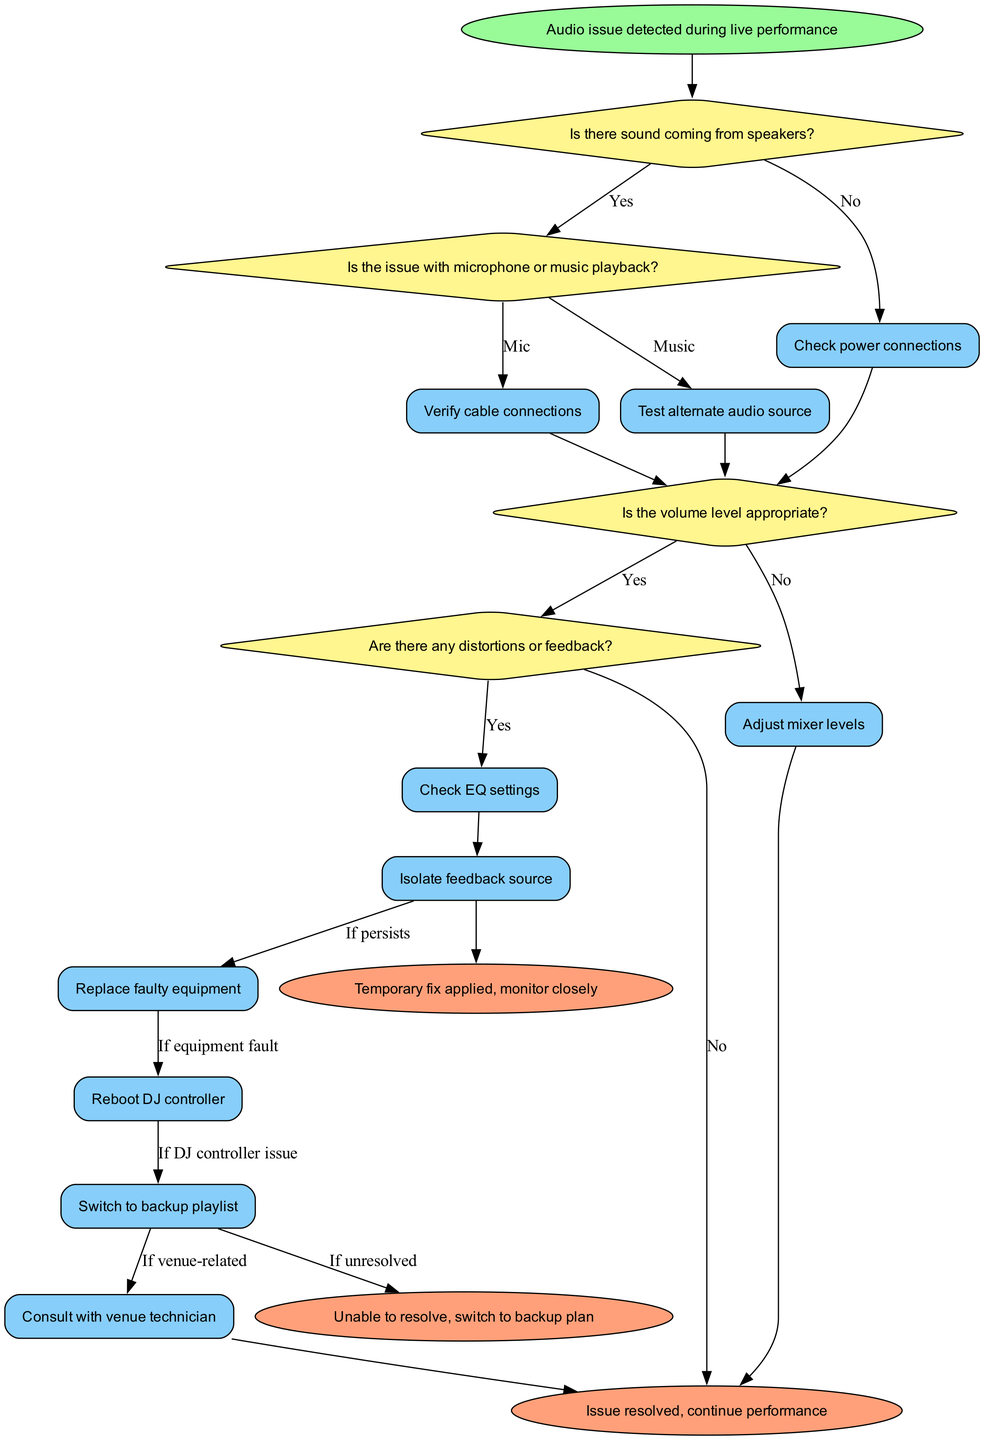What is the first action if there is no sound coming from the speakers? According to the diagram flow, if there is no sound coming from the speakers, the first action to take is to check power connections. This follows directly from the initial decision point at the start node.
Answer: Check power connections How many decision points are present in the flowchart? The flowchart contains four decision points that are essential for troubleshooting the audio issue. These decision points guide the troubleshooting process based on the identified audio problems.
Answer: Four What action follows if the microphone is identified as the issue? If the issue is identified with the microphone, the next action is to verify cable connections. This is directly indicated by the flowchart's connection between the decision point for the microphone and the corresponding action for cable verification.
Answer: Verify cable connections What is the last action taken if the audio issue persists? If the audio issue continues to be unresolved, the last action taken would be to switch to a backup playlist. This action follows the flow from the failure to resolve the issue despite earlier troubleshooting steps.
Answer: Switch to backup playlist What decision follows after adjusting mixer levels? After adjusting mixer levels, the next decision is to check EQ settings. This sequence is evident from the flowchart where adjusting mixer levels leads to another decision point regarding EQ settings.
Answer: Check EQ settings What happens if feedback is identified as an issue? If feedback is detected as a problem, the troubleshooting step involves isolating the feedback source. This step is part of the logic outlined in the flowchart for addressing feedback-related audio issues.
Answer: Isolate feedback source What is the end result if the issue is resolved? If the audio issue is resolved, the end result is to continue the performance. This outcome is indicated in the flowchart as a successful resolution of audio troubleshooting.
Answer: Continue performance What is a temporary fix indicated in the flowchart? A temporary fix that can be applied is to monitor closely after resolving the issue temporarily. This step reflects a cautious approach to ensure the audio quality remains stable during the performance.
Answer: Temporary fix applied, monitor closely 